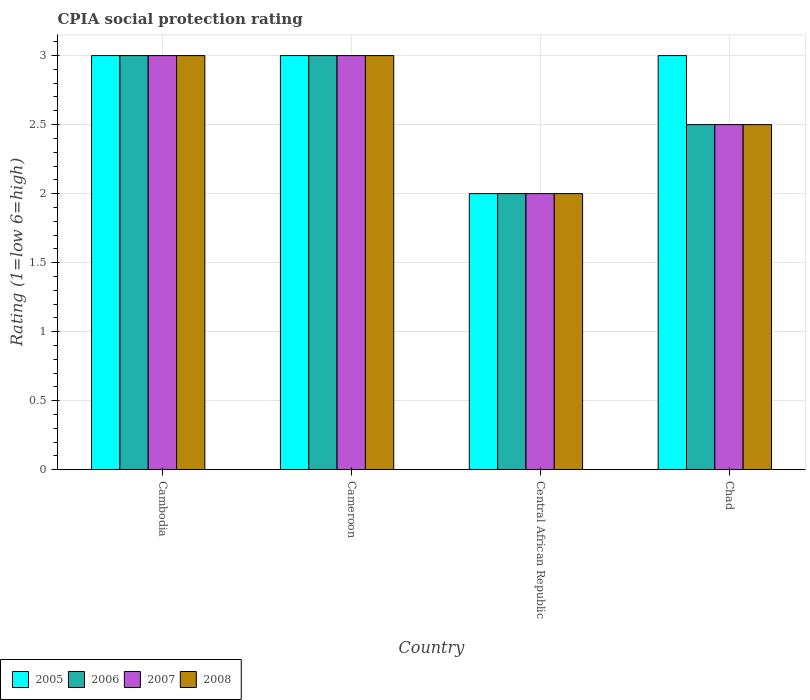Are the number of bars per tick equal to the number of legend labels?
Your answer should be compact. Yes. Are the number of bars on each tick of the X-axis equal?
Make the answer very short. Yes. How many bars are there on the 1st tick from the left?
Your answer should be very brief. 4. What is the label of the 3rd group of bars from the left?
Give a very brief answer. Central African Republic. In how many cases, is the number of bars for a given country not equal to the number of legend labels?
Provide a short and direct response. 0. What is the CPIA rating in 2007 in Cameroon?
Your response must be concise. 3. Across all countries, what is the minimum CPIA rating in 2006?
Offer a terse response. 2. In which country was the CPIA rating in 2008 maximum?
Keep it short and to the point. Cambodia. In which country was the CPIA rating in 2007 minimum?
Ensure brevity in your answer.  Central African Republic. What is the total CPIA rating in 2007 in the graph?
Provide a short and direct response. 10.5. What is the difference between the CPIA rating in 2006 in Cameroon and that in Central African Republic?
Offer a terse response. 1. What is the average CPIA rating in 2005 per country?
Keep it short and to the point. 2.75. What is the difference between the CPIA rating of/in 2005 and CPIA rating of/in 2008 in Central African Republic?
Provide a short and direct response. 0. In how many countries, is the CPIA rating in 2008 greater than 2.7?
Make the answer very short. 2. Is the CPIA rating in 2006 in Central African Republic less than that in Chad?
Keep it short and to the point. Yes. What is the difference between the highest and the lowest CPIA rating in 2006?
Make the answer very short. 1. Is it the case that in every country, the sum of the CPIA rating in 2006 and CPIA rating in 2005 is greater than the sum of CPIA rating in 2007 and CPIA rating in 2008?
Your answer should be very brief. No. What does the 1st bar from the left in Chad represents?
Offer a terse response. 2005. What does the 2nd bar from the right in Cameroon represents?
Offer a terse response. 2007. How many bars are there?
Give a very brief answer. 16. Are all the bars in the graph horizontal?
Ensure brevity in your answer.  No. Are the values on the major ticks of Y-axis written in scientific E-notation?
Your answer should be compact. No. Where does the legend appear in the graph?
Provide a succinct answer. Bottom left. How are the legend labels stacked?
Your answer should be compact. Horizontal. What is the title of the graph?
Ensure brevity in your answer.  CPIA social protection rating. Does "1960" appear as one of the legend labels in the graph?
Keep it short and to the point. No. What is the label or title of the X-axis?
Your answer should be very brief. Country. What is the label or title of the Y-axis?
Ensure brevity in your answer.  Rating (1=low 6=high). What is the Rating (1=low 6=high) in 2006 in Cambodia?
Your answer should be compact. 3. What is the Rating (1=low 6=high) of 2006 in Cameroon?
Provide a short and direct response. 3. What is the Rating (1=low 6=high) in 2007 in Cameroon?
Your answer should be compact. 3. What is the Rating (1=low 6=high) of 2005 in Central African Republic?
Provide a succinct answer. 2. What is the Rating (1=low 6=high) of 2005 in Chad?
Keep it short and to the point. 3. What is the Rating (1=low 6=high) in 2006 in Chad?
Your answer should be compact. 2.5. What is the Rating (1=low 6=high) in 2007 in Chad?
Your answer should be very brief. 2.5. Across all countries, what is the maximum Rating (1=low 6=high) of 2007?
Provide a succinct answer. 3. Across all countries, what is the minimum Rating (1=low 6=high) of 2007?
Offer a terse response. 2. Across all countries, what is the minimum Rating (1=low 6=high) in 2008?
Your response must be concise. 2. What is the total Rating (1=low 6=high) of 2005 in the graph?
Your answer should be compact. 11. What is the total Rating (1=low 6=high) in 2006 in the graph?
Keep it short and to the point. 10.5. What is the difference between the Rating (1=low 6=high) in 2008 in Cambodia and that in Cameroon?
Your answer should be very brief. 0. What is the difference between the Rating (1=low 6=high) in 2005 in Cambodia and that in Central African Republic?
Your answer should be compact. 1. What is the difference between the Rating (1=low 6=high) of 2008 in Cambodia and that in Central African Republic?
Keep it short and to the point. 1. What is the difference between the Rating (1=low 6=high) in 2005 in Cambodia and that in Chad?
Offer a terse response. 0. What is the difference between the Rating (1=low 6=high) in 2006 in Cambodia and that in Chad?
Offer a very short reply. 0.5. What is the difference between the Rating (1=low 6=high) in 2007 in Cameroon and that in Central African Republic?
Your response must be concise. 1. What is the difference between the Rating (1=low 6=high) of 2008 in Cameroon and that in Central African Republic?
Provide a succinct answer. 1. What is the difference between the Rating (1=low 6=high) of 2005 in Cameroon and that in Chad?
Provide a succinct answer. 0. What is the difference between the Rating (1=low 6=high) of 2006 in Cameroon and that in Chad?
Provide a short and direct response. 0.5. What is the difference between the Rating (1=low 6=high) in 2008 in Central African Republic and that in Chad?
Keep it short and to the point. -0.5. What is the difference between the Rating (1=low 6=high) in 2006 in Cambodia and the Rating (1=low 6=high) in 2008 in Cameroon?
Make the answer very short. 0. What is the difference between the Rating (1=low 6=high) in 2005 in Cambodia and the Rating (1=low 6=high) in 2007 in Central African Republic?
Keep it short and to the point. 1. What is the difference between the Rating (1=low 6=high) of 2007 in Cambodia and the Rating (1=low 6=high) of 2008 in Central African Republic?
Offer a very short reply. 1. What is the difference between the Rating (1=low 6=high) of 2005 in Cambodia and the Rating (1=low 6=high) of 2008 in Chad?
Provide a short and direct response. 0.5. What is the difference between the Rating (1=low 6=high) in 2007 in Cambodia and the Rating (1=low 6=high) in 2008 in Chad?
Provide a short and direct response. 0.5. What is the difference between the Rating (1=low 6=high) in 2005 in Cameroon and the Rating (1=low 6=high) in 2008 in Central African Republic?
Keep it short and to the point. 1. What is the difference between the Rating (1=low 6=high) in 2006 in Cameroon and the Rating (1=low 6=high) in 2008 in Central African Republic?
Provide a short and direct response. 1. What is the difference between the Rating (1=low 6=high) in 2005 in Cameroon and the Rating (1=low 6=high) in 2008 in Chad?
Your response must be concise. 0.5. What is the difference between the Rating (1=low 6=high) in 2006 in Cameroon and the Rating (1=low 6=high) in 2008 in Chad?
Provide a short and direct response. 0.5. What is the difference between the Rating (1=low 6=high) of 2007 in Cameroon and the Rating (1=low 6=high) of 2008 in Chad?
Offer a very short reply. 0.5. What is the difference between the Rating (1=low 6=high) in 2005 in Central African Republic and the Rating (1=low 6=high) in 2008 in Chad?
Offer a terse response. -0.5. What is the difference between the Rating (1=low 6=high) of 2006 in Central African Republic and the Rating (1=low 6=high) of 2008 in Chad?
Make the answer very short. -0.5. What is the average Rating (1=low 6=high) in 2005 per country?
Ensure brevity in your answer.  2.75. What is the average Rating (1=low 6=high) in 2006 per country?
Offer a very short reply. 2.62. What is the average Rating (1=low 6=high) in 2007 per country?
Your answer should be compact. 2.62. What is the average Rating (1=low 6=high) in 2008 per country?
Offer a terse response. 2.62. What is the difference between the Rating (1=low 6=high) of 2006 and Rating (1=low 6=high) of 2007 in Cambodia?
Your answer should be very brief. 0. What is the difference between the Rating (1=low 6=high) in 2005 and Rating (1=low 6=high) in 2006 in Cameroon?
Offer a terse response. 0. What is the difference between the Rating (1=low 6=high) in 2006 and Rating (1=low 6=high) in 2007 in Cameroon?
Ensure brevity in your answer.  0. What is the difference between the Rating (1=low 6=high) of 2006 and Rating (1=low 6=high) of 2008 in Cameroon?
Offer a terse response. 0. What is the difference between the Rating (1=low 6=high) of 2005 and Rating (1=low 6=high) of 2007 in Central African Republic?
Give a very brief answer. 0. What is the difference between the Rating (1=low 6=high) in 2006 and Rating (1=low 6=high) in 2007 in Central African Republic?
Your response must be concise. 0. What is the difference between the Rating (1=low 6=high) of 2006 and Rating (1=low 6=high) of 2008 in Central African Republic?
Offer a terse response. 0. What is the difference between the Rating (1=low 6=high) of 2007 and Rating (1=low 6=high) of 2008 in Central African Republic?
Give a very brief answer. 0. What is the difference between the Rating (1=low 6=high) in 2005 and Rating (1=low 6=high) in 2006 in Chad?
Offer a very short reply. 0.5. What is the difference between the Rating (1=low 6=high) in 2005 and Rating (1=low 6=high) in 2007 in Chad?
Give a very brief answer. 0.5. What is the difference between the Rating (1=low 6=high) in 2005 and Rating (1=low 6=high) in 2008 in Chad?
Your response must be concise. 0.5. What is the difference between the Rating (1=low 6=high) in 2007 and Rating (1=low 6=high) in 2008 in Chad?
Provide a short and direct response. 0. What is the ratio of the Rating (1=low 6=high) in 2005 in Cambodia to that in Cameroon?
Give a very brief answer. 1. What is the ratio of the Rating (1=low 6=high) of 2008 in Cambodia to that in Cameroon?
Provide a succinct answer. 1. What is the ratio of the Rating (1=low 6=high) of 2005 in Cambodia to that in Central African Republic?
Your answer should be compact. 1.5. What is the ratio of the Rating (1=low 6=high) of 2006 in Cambodia to that in Central African Republic?
Provide a short and direct response. 1.5. What is the ratio of the Rating (1=low 6=high) in 2006 in Cambodia to that in Chad?
Provide a succinct answer. 1.2. What is the ratio of the Rating (1=low 6=high) of 2008 in Cambodia to that in Chad?
Ensure brevity in your answer.  1.2. What is the ratio of the Rating (1=low 6=high) of 2007 in Cameroon to that in Central African Republic?
Provide a succinct answer. 1.5. What is the ratio of the Rating (1=low 6=high) in 2008 in Cameroon to that in Central African Republic?
Offer a very short reply. 1.5. What is the ratio of the Rating (1=low 6=high) of 2005 in Cameroon to that in Chad?
Ensure brevity in your answer.  1. What is the ratio of the Rating (1=low 6=high) in 2007 in Cameroon to that in Chad?
Keep it short and to the point. 1.2. What is the ratio of the Rating (1=low 6=high) of 2005 in Central African Republic to that in Chad?
Make the answer very short. 0.67. What is the ratio of the Rating (1=low 6=high) of 2006 in Central African Republic to that in Chad?
Ensure brevity in your answer.  0.8. What is the ratio of the Rating (1=low 6=high) of 2007 in Central African Republic to that in Chad?
Offer a terse response. 0.8. What is the difference between the highest and the second highest Rating (1=low 6=high) of 2005?
Provide a succinct answer. 0. What is the difference between the highest and the lowest Rating (1=low 6=high) of 2006?
Give a very brief answer. 1. What is the difference between the highest and the lowest Rating (1=low 6=high) of 2007?
Provide a succinct answer. 1. 